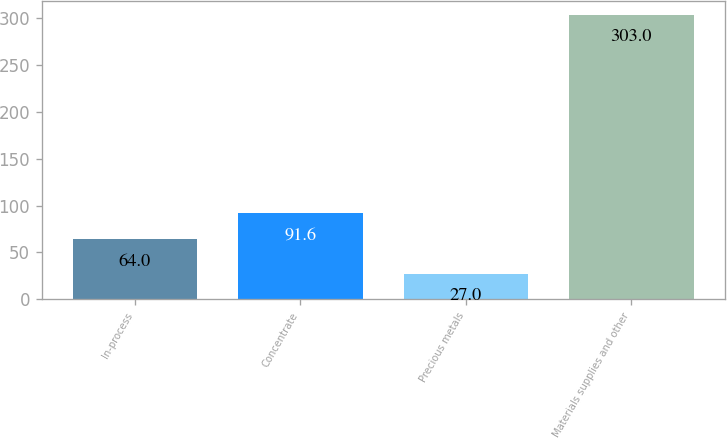Convert chart to OTSL. <chart><loc_0><loc_0><loc_500><loc_500><bar_chart><fcel>In-process<fcel>Concentrate<fcel>Precious metals<fcel>Materials supplies and other<nl><fcel>64<fcel>91.6<fcel>27<fcel>303<nl></chart> 